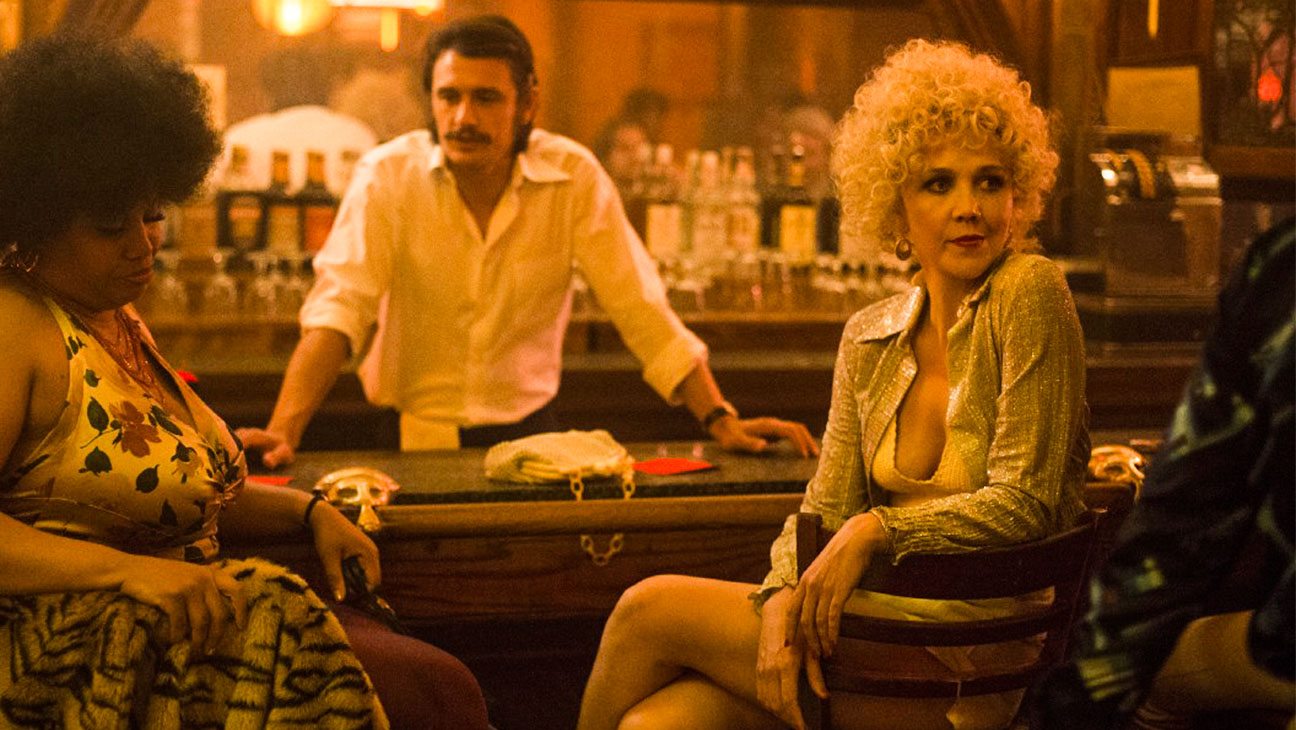What are the key elements in this picture? The image features a cinematic scene set in a bar. Pivotal elements include a central female character with curly blonde hair, dressed in a glamorous gold sequin jacket. She is surrounded by other intriguing characters: to her left, a woman with a floral dress and afro hairstyle, and to her right, a man in a white shirt with a mustache, suggesting a 1970s setting. The dim bar environment is complemented by subtle lighting that focuses on the central character, enhancing the nostalgic and moody atmosphere. These elements come together to illustrate a story-rich setting, likely from a film or television series. 